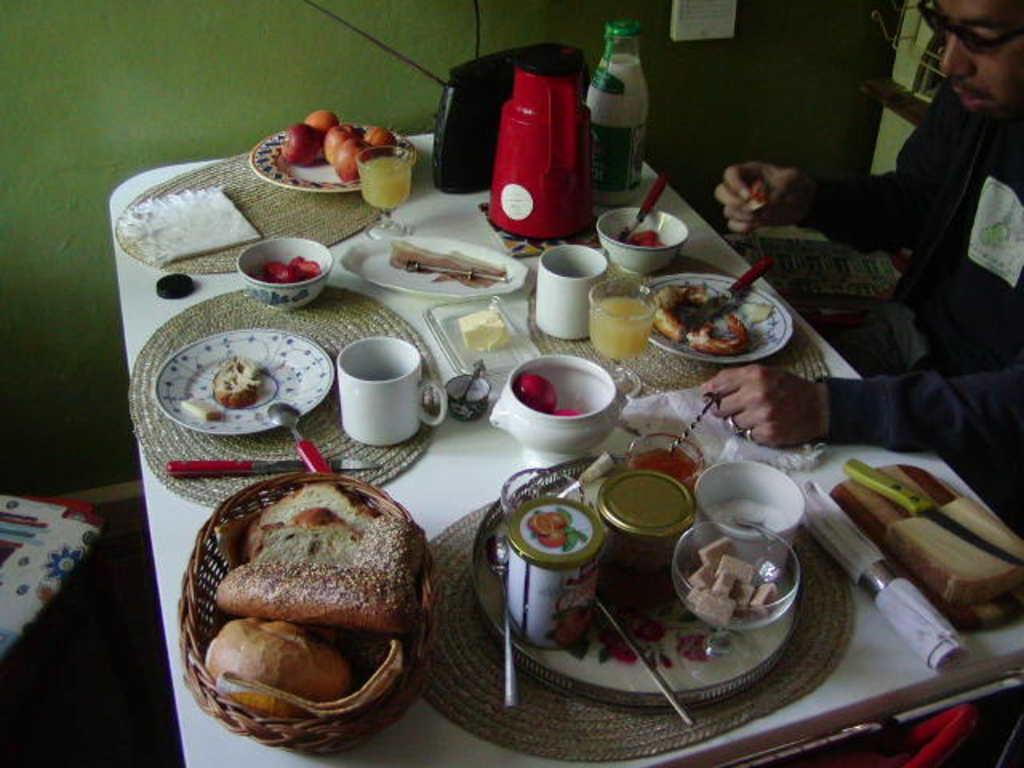How would you summarize this image in a sentence or two? This image is clicked in a room. In the front, there is a table in white color on which, there are baskets, food and cups along with bottle. To the right, there is a man sitting and wearing black dress. In the background, there is a wall in green color. To the left, there is a chair. 